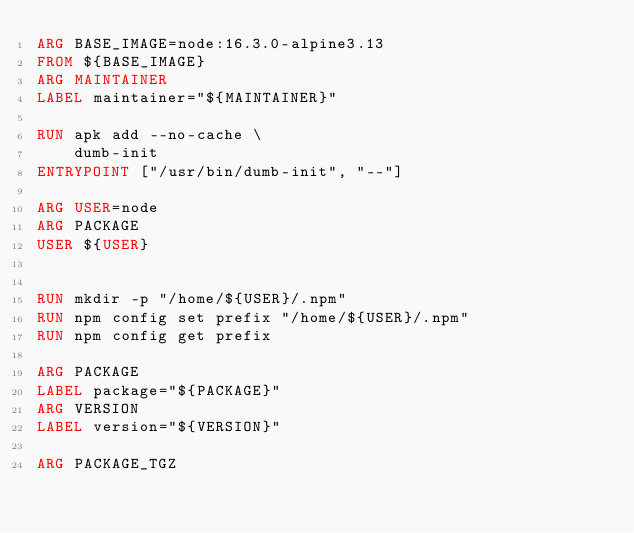<code> <loc_0><loc_0><loc_500><loc_500><_Dockerfile_>ARG BASE_IMAGE=node:16.3.0-alpine3.13
FROM ${BASE_IMAGE}
ARG MAINTAINER
LABEL maintainer="${MAINTAINER}"

RUN apk add --no-cache \
    dumb-init
ENTRYPOINT ["/usr/bin/dumb-init", "--"]

ARG USER=node
ARG PACKAGE
USER ${USER}


RUN mkdir -p "/home/${USER}/.npm"
RUN npm config set prefix "/home/${USER}/.npm"
RUN npm config get prefix

ARG PACKAGE
LABEL package="${PACKAGE}"
ARG VERSION
LABEL version="${VERSION}"

ARG PACKAGE_TGZ</code> 